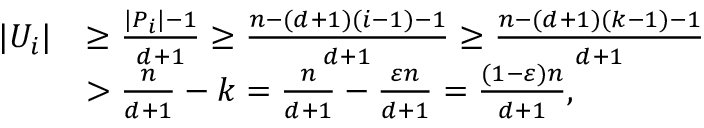Convert formula to latex. <formula><loc_0><loc_0><loc_500><loc_500>\begin{array} { r l } { | U _ { i } | } & { \geq \frac { | P _ { i } | - 1 } { d + 1 } \geq \frac { n - ( d + 1 ) ( i - 1 ) - 1 } { d + 1 } \geq \frac { n - ( d + 1 ) ( k - 1 ) - 1 } { d + 1 } } \\ & { > \frac { n } { d + 1 } - k = \frac { n } { d + 1 } - \frac { \varepsilon n } { d + 1 } = \frac { ( 1 - \varepsilon ) n } { d + 1 } , } \end{array}</formula> 